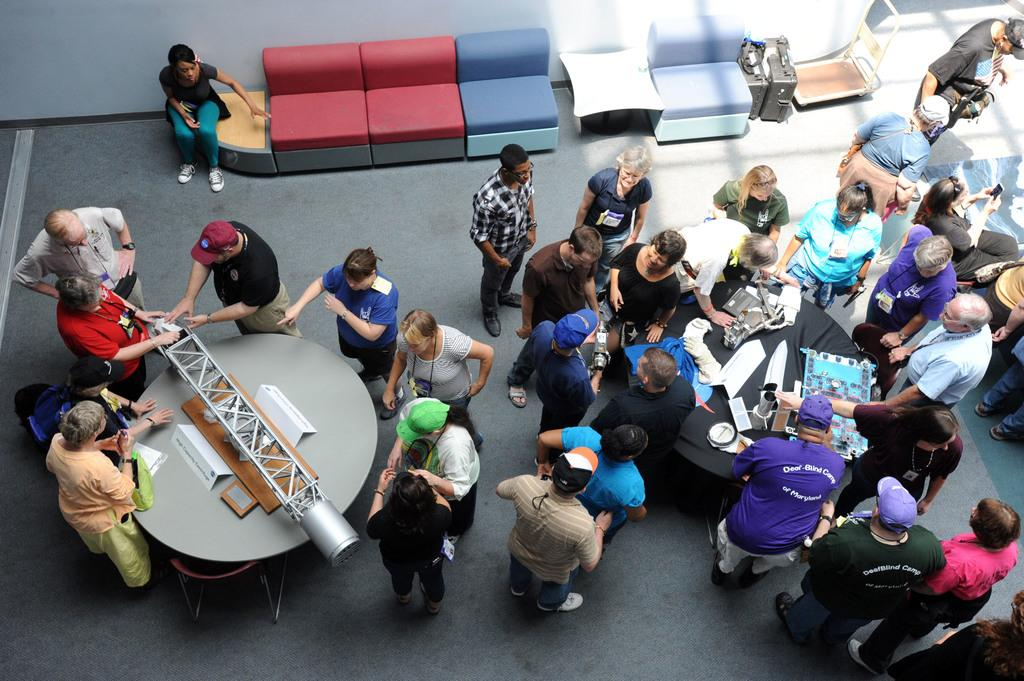What is the primary activity of the people in the image? The people in the image are standing near tables, which suggests they might be attending an event or gathering. Can you describe the furniture in the background of the image? There is a sofa in the background of the image. What type of yak can be seen grazing near the tables in the image? There is no yak present in the image; it features people standing near tables and a sofa in the background. 